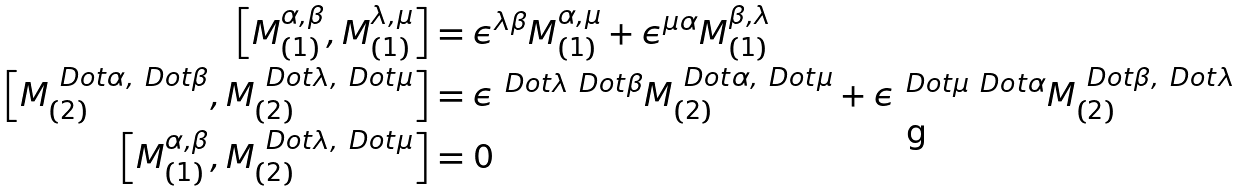Convert formula to latex. <formula><loc_0><loc_0><loc_500><loc_500>\left [ M ^ { \alpha , \beta } _ { ( 1 ) } , M ^ { \lambda , \mu } _ { ( 1 ) } \right ] & = \epsilon ^ { \lambda \beta } M ^ { \alpha , \mu } _ { ( 1 ) } + \epsilon ^ { \mu \alpha } M ^ { \beta , \lambda } _ { ( 1 ) } \\ \left [ M ^ { \ D o t { \alpha } , \ D o t { \beta } } _ { ( 2 ) } , M ^ { \ D o t { \lambda } , \ D o t { \mu } } _ { ( 2 ) } \right ] & = \epsilon ^ { \ D o t { \lambda } \ D o t { \beta } } M ^ { \ D o t { \alpha } , \ D o t { \mu } } _ { ( 2 ) } + \epsilon ^ { \ D o t { \mu } \ D o t { \alpha } } M ^ { \ D o t { \beta } , \ D o t { \lambda } } _ { ( 2 ) } \\ \left [ M ^ { \alpha , \beta } _ { ( 1 ) } , M ^ { \ D o t { \lambda } , \ D o t { \mu } } _ { ( 2 ) } \right ] & = 0</formula> 